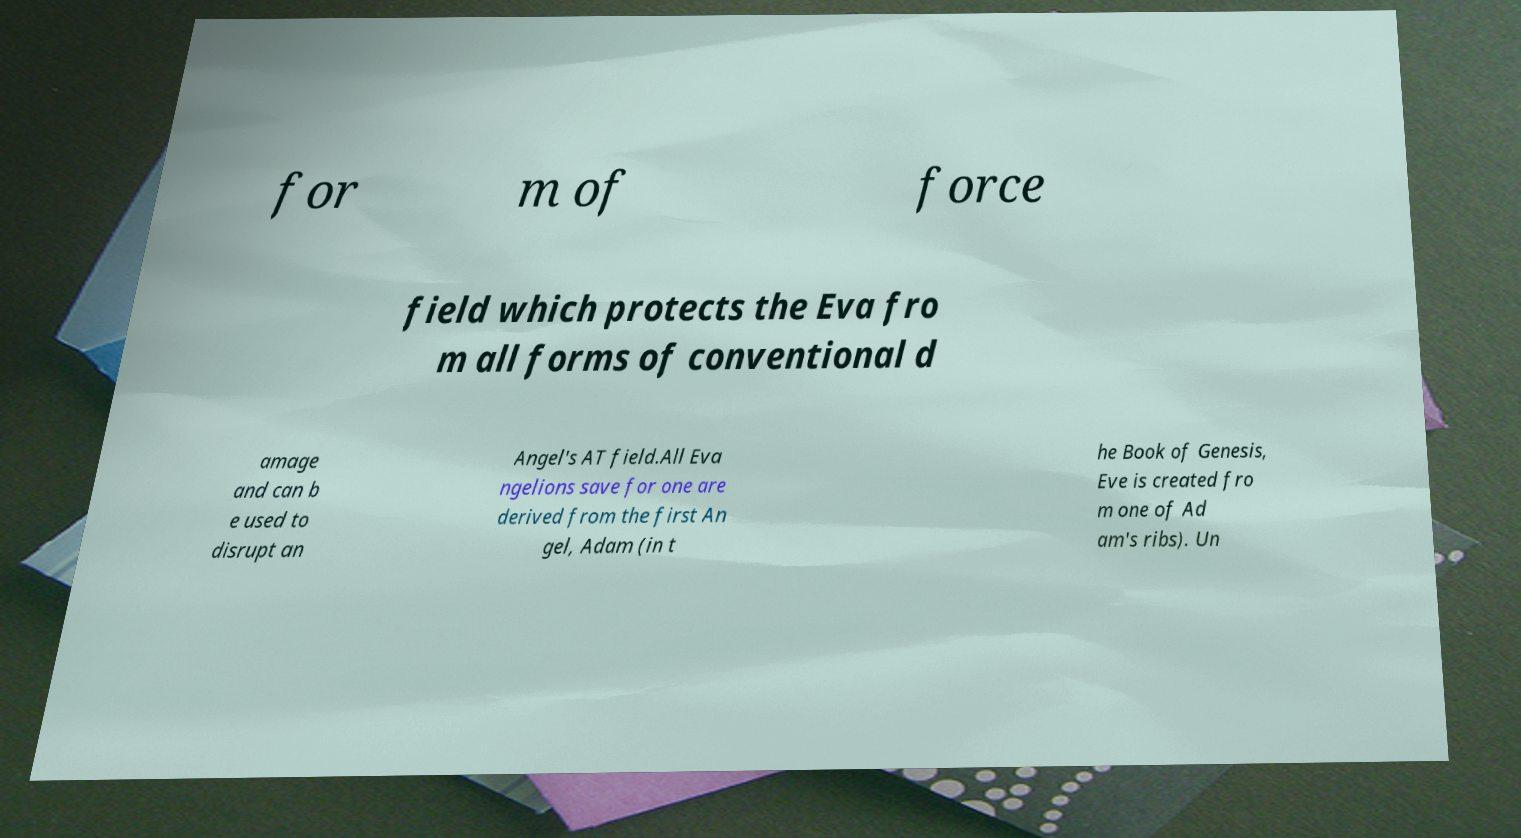There's text embedded in this image that I need extracted. Can you transcribe it verbatim? for m of force field which protects the Eva fro m all forms of conventional d amage and can b e used to disrupt an Angel's AT field.All Eva ngelions save for one are derived from the first An gel, Adam (in t he Book of Genesis, Eve is created fro m one of Ad am's ribs). Un 